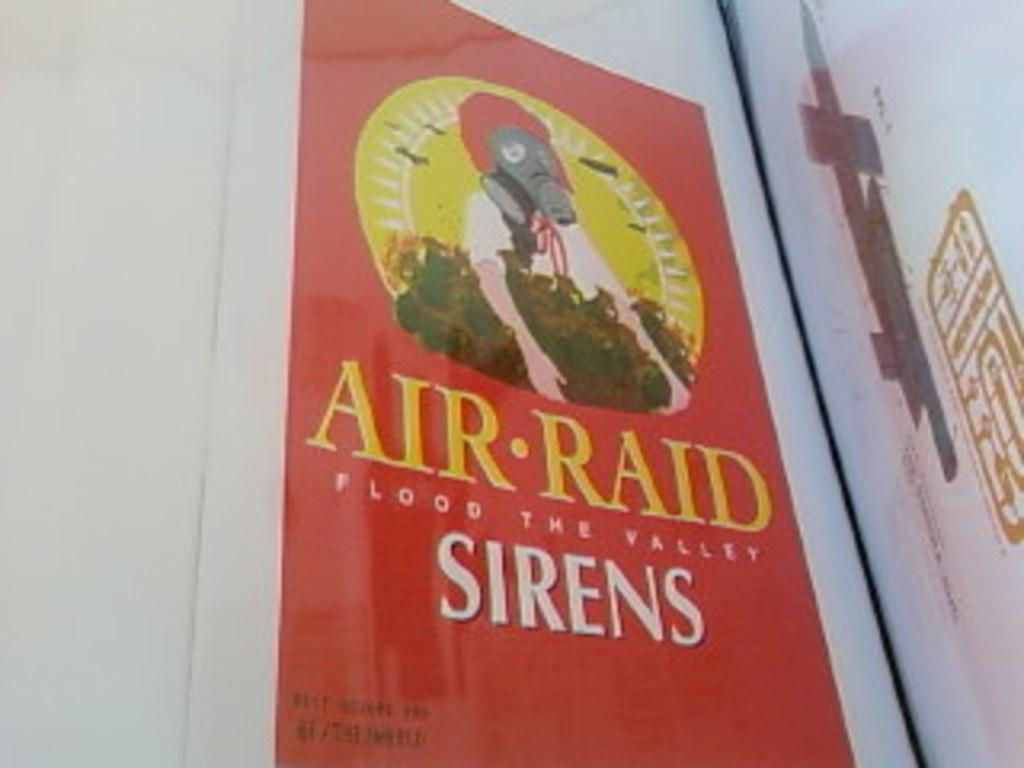<image>
Give a short and clear explanation of the subsequent image. A advertisement of a box Air Raid Flood The Valley Sirens. 